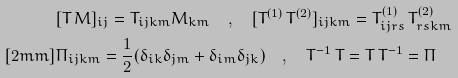<formula> <loc_0><loc_0><loc_500><loc_500>& [ T \, M ] _ { i j } = T _ { i j k m } M _ { k m } \quad , \quad [ T ^ { ( 1 ) } \, T ^ { ( 2 ) } ] _ { i j k m } = T ^ { ( 1 ) } _ { i j r s } \, T ^ { ( 2 ) } _ { r s k m } \\ [ 2 m m ] & \Pi _ { i j k m } = \frac { 1 } { 2 } ( \delta _ { i k } \delta _ { j m } + \delta _ { i m } \delta _ { j k } ) \quad , \quad T ^ { - 1 } \, T = T \, T ^ { - 1 } = \Pi</formula> 